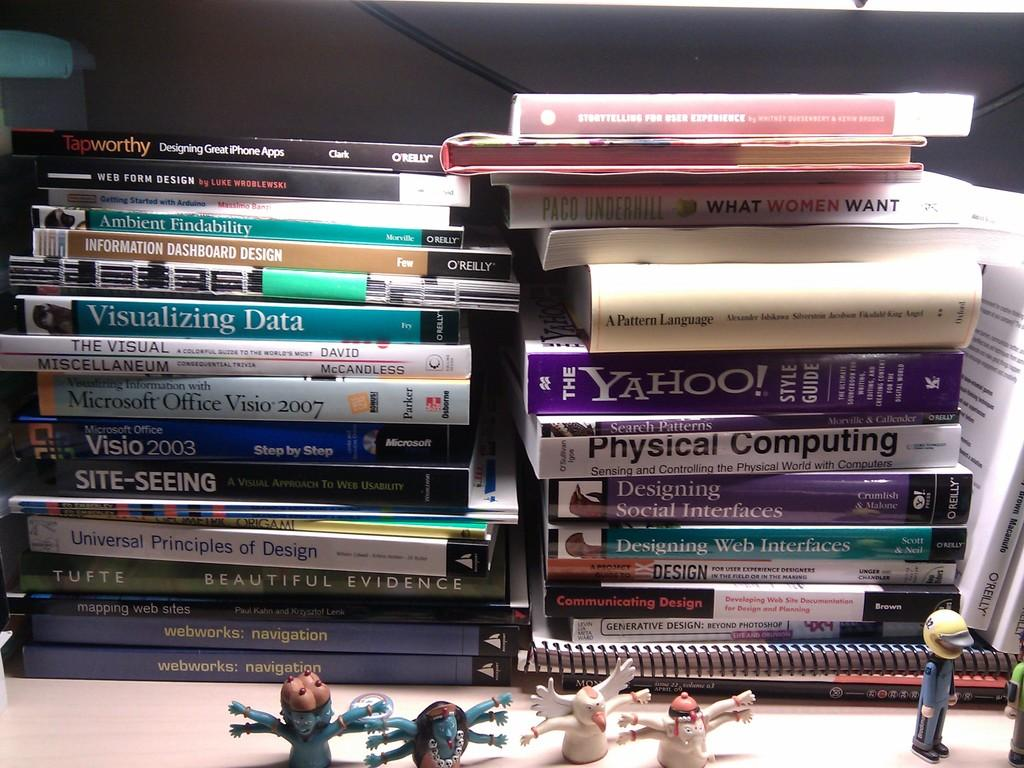Provide a one-sentence caption for the provided image. Two large stacks of computer books sit on a desk including guides about visualizing data and physical computing. 